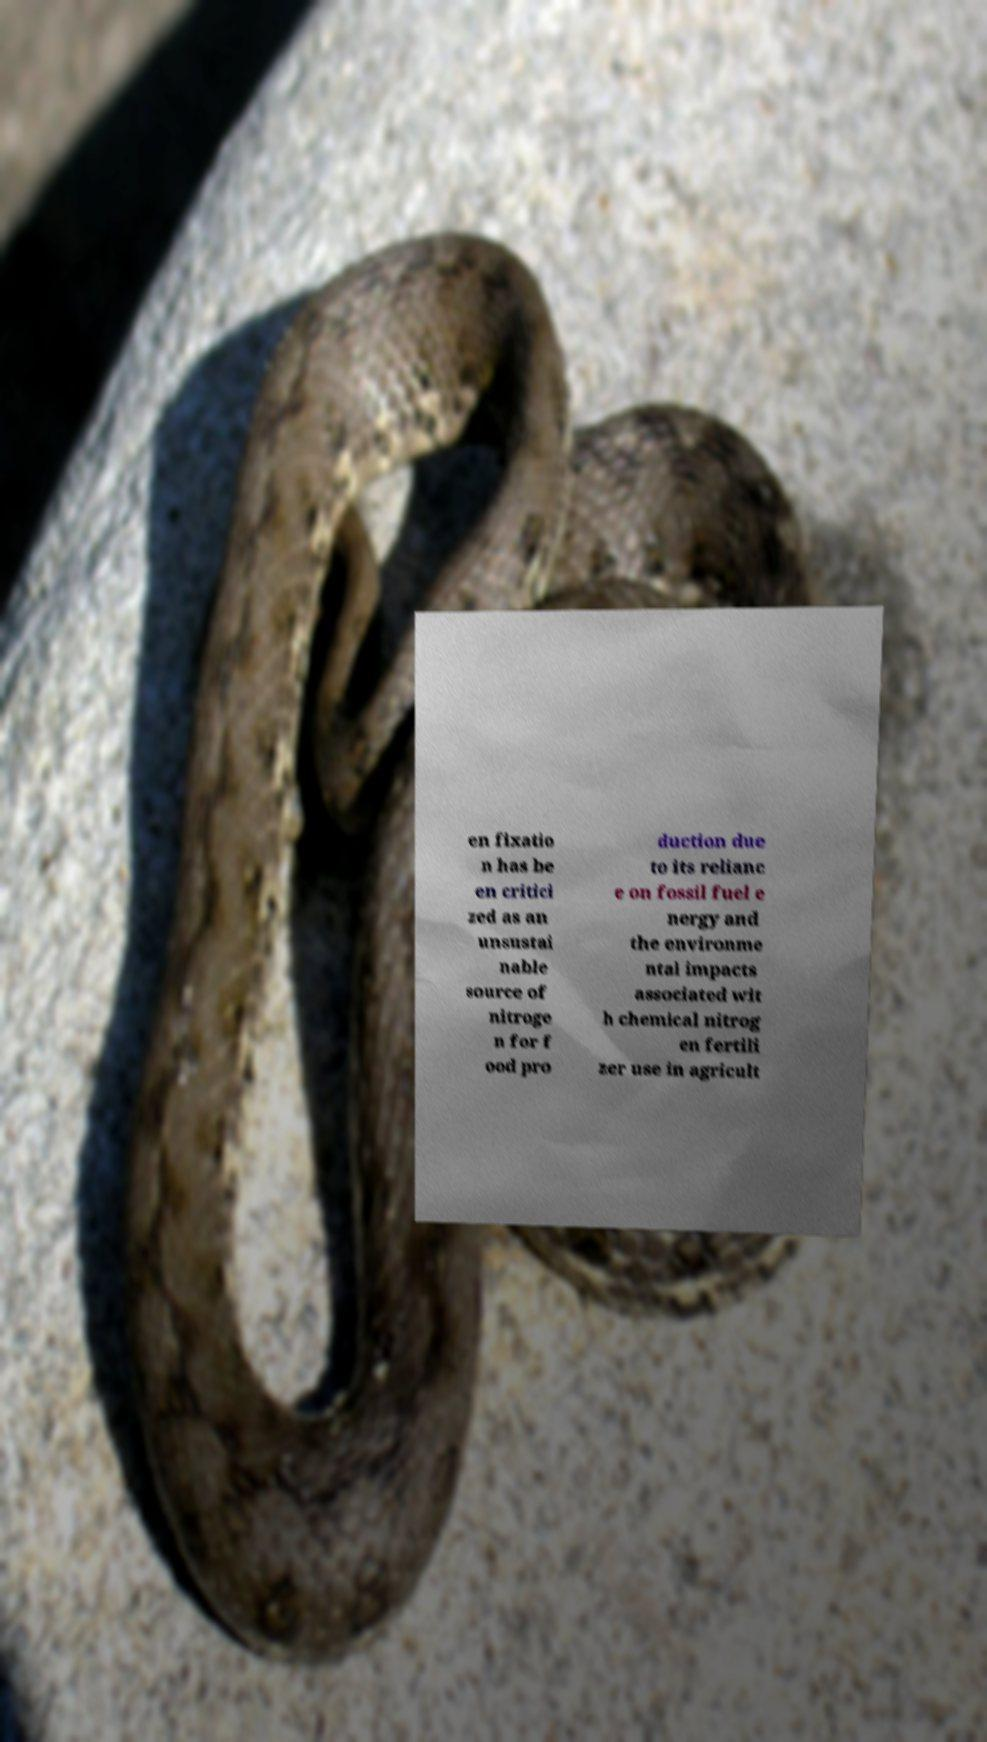Can you accurately transcribe the text from the provided image for me? en fixatio n has be en critici zed as an unsustai nable source of nitroge n for f ood pro duction due to its relianc e on fossil fuel e nergy and the environme ntal impacts associated wit h chemical nitrog en fertili zer use in agricult 